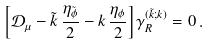Convert formula to latex. <formula><loc_0><loc_0><loc_500><loc_500>\left [ \mathcal { D } _ { \mu } - \tilde { k } \, \frac { \eta _ { \tilde { \phi } } } { 2 } - k \, \frac { \eta _ { \phi } } { 2 } \right ] \gamma ^ { ( \tilde { k } ; k ) } _ { R } = 0 \, .</formula> 